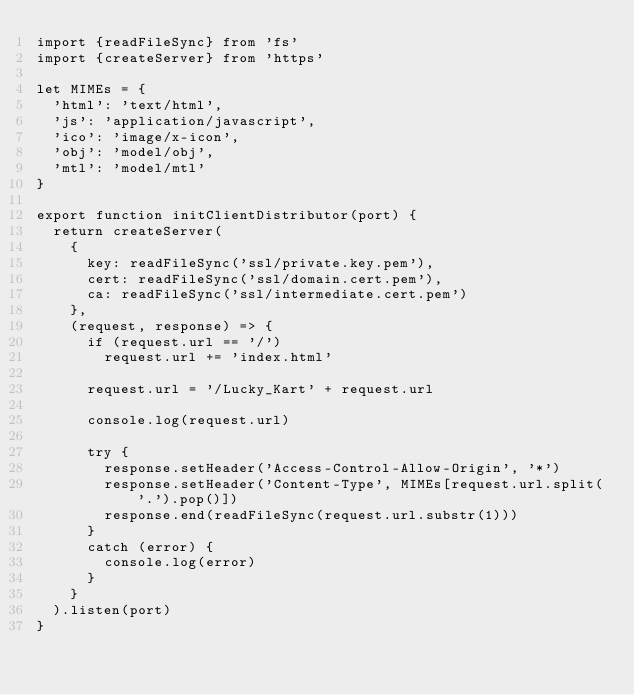<code> <loc_0><loc_0><loc_500><loc_500><_JavaScript_>import {readFileSync} from 'fs'
import {createServer} from 'https'

let MIMEs = {
	'html': 'text/html',
	'js': 'application/javascript',
	'ico': 'image/x-icon',
	'obj': 'model/obj',
	'mtl': 'model/mtl'
}

export function initClientDistributor(port) {
	return createServer(
		{
			key: readFileSync('ssl/private.key.pem'),
			cert: readFileSync('ssl/domain.cert.pem'),
			ca: readFileSync('ssl/intermediate.cert.pem')
		},
		(request, response) => {
			if (request.url == '/')
				request.url += 'index.html'

			request.url = '/Lucky_Kart' + request.url

			console.log(request.url)

			try {
				response.setHeader('Access-Control-Allow-Origin', '*')
				response.setHeader('Content-Type', MIMEs[request.url.split('.').pop()])
				response.end(readFileSync(request.url.substr(1)))
			}
			catch (error) {
				console.log(error)
			}
		}
	).listen(port)
}</code> 